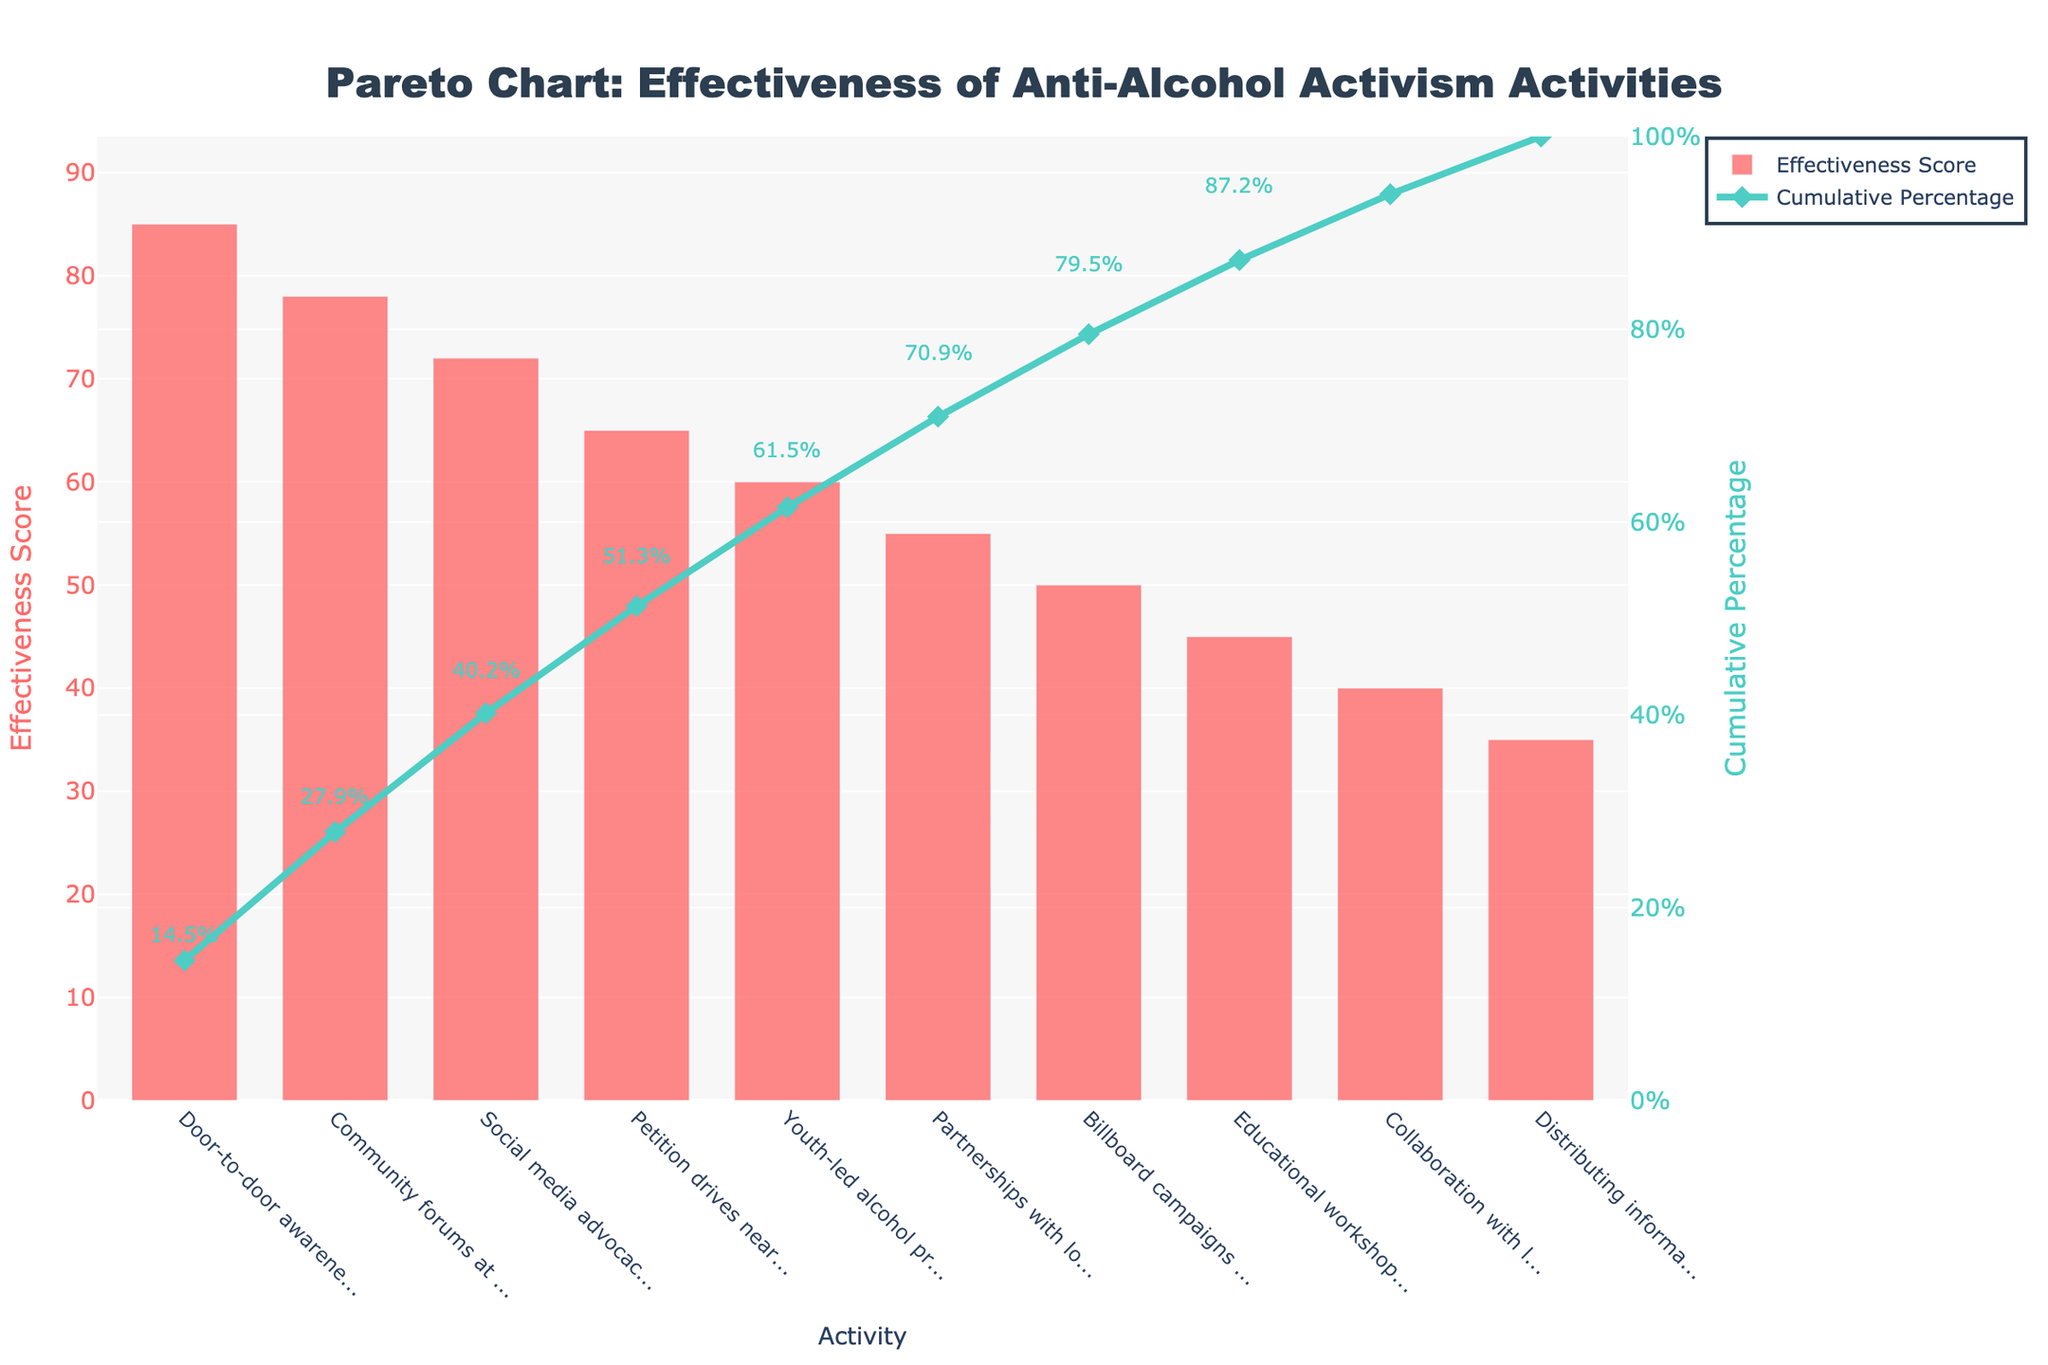What's the title of the figure? The title is typically located at the very top of the figure, and in this case, it states "Pareto Chart: Effectiveness of Anti-Alcohol Activism Activities".
Answer: Pareto Chart: Effectiveness of Anti-Alcohol Activism Activities What is the effectiveness score for Social media advocacy? The bar corresponding to "Social media advocacy" reaches up to the value of 72 on the y-axis labeled "Effectiveness Score".
Answer: 72 Which activity is considered the most effective? The first bar on the left, representing the activity with the highest effectiveness score, is "Door-to-door awareness campaigns" with a score of 85.
Answer: Door-to-door awareness campaigns What is the cumulative percentage reached after the third activity? The line representing the cumulative percentage intersects the y-axis labeled "Cumulative Percentage" and reaches approximately 72% after the first three activities: Door-to-door awareness campaigns, Community forums at local schools, and Social media advocacy.
Answer: 72% How many activities have an effectiveness score of 50 or higher? By examining the bars and their corresponding values, the activities with scores of 50 or higher are Door-to-door awareness campaigns (85), Community forums at local schools (78), Social media advocacy (72), Petition drives near school zones (65), Youth-led alcohol prevention programs (60), and Billboard campaigns in Honolulu (50). There are six such activities.
Answer: 6 Which activity has the least effectiveness score and what is its score? The last bar from the left representing "Distributing informational flyers" has the lowest effectiveness score of 35.
Answer: Distributing informational flyers, 35 What is the cumulative percentage for "Partnerships with local PTA groups"? By looking at where the line chart crosses on top of the bar for "Partnerships with local PTA groups", the cumulative percentage is around 68%.
Answer: 68% Compare the effectiveness score of "Youth-led alcohol prevention programs" and "Petition drives near school zones". Which one is higher and by how much? "Petition drives near school zones" has an effectiveness score of 65, whereas "Youth-led alcohol prevention programs" has a score of 60. The difference between them is 5, indicating that the petition drives are slightly more effective.
Answer: Petition drives near school zones by 5 If we sum the effectiveness scores of the first three activities, what do we get? Adding up the effectiveness scores of Door-to-door awareness campaigns (85), Community forums at local schools (78), and Social media advocacy (72) calculates to 85 + 78 + 72 = 235.
Answer: 235 